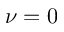Convert formula to latex. <formula><loc_0><loc_0><loc_500><loc_500>\nu = 0</formula> 